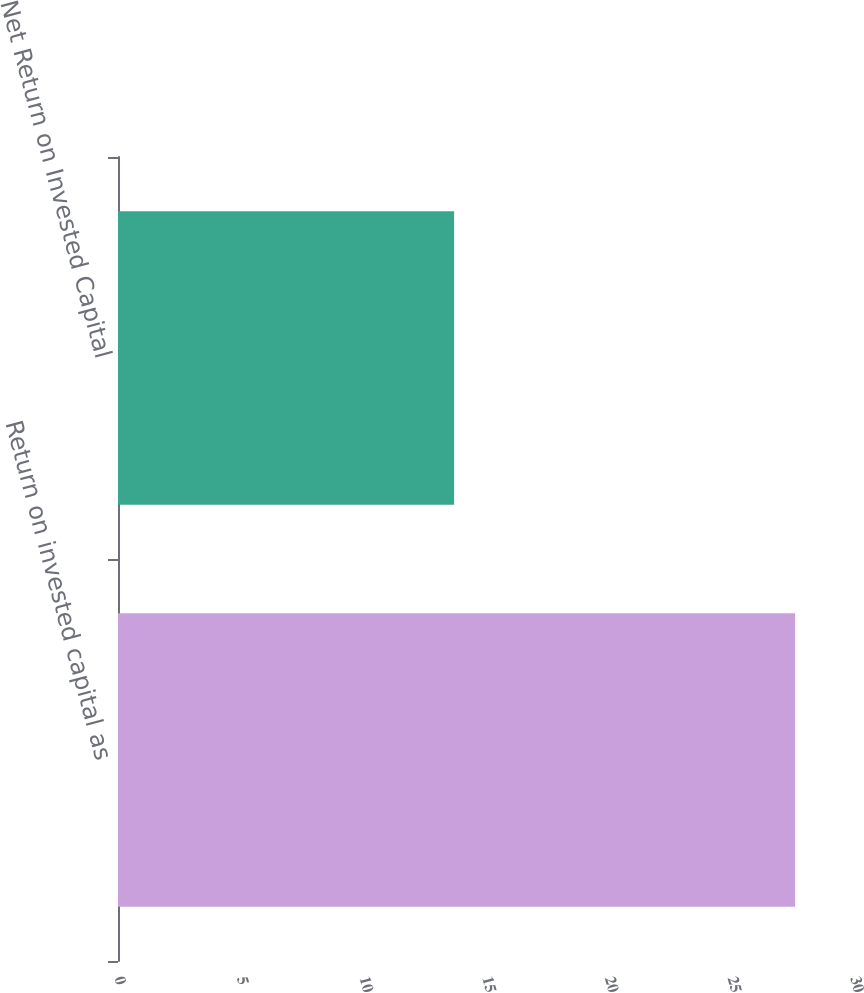Convert chart. <chart><loc_0><loc_0><loc_500><loc_500><bar_chart><fcel>Return on invested capital as<fcel>Net Return on Invested Capital<nl><fcel>27.6<fcel>13.7<nl></chart> 